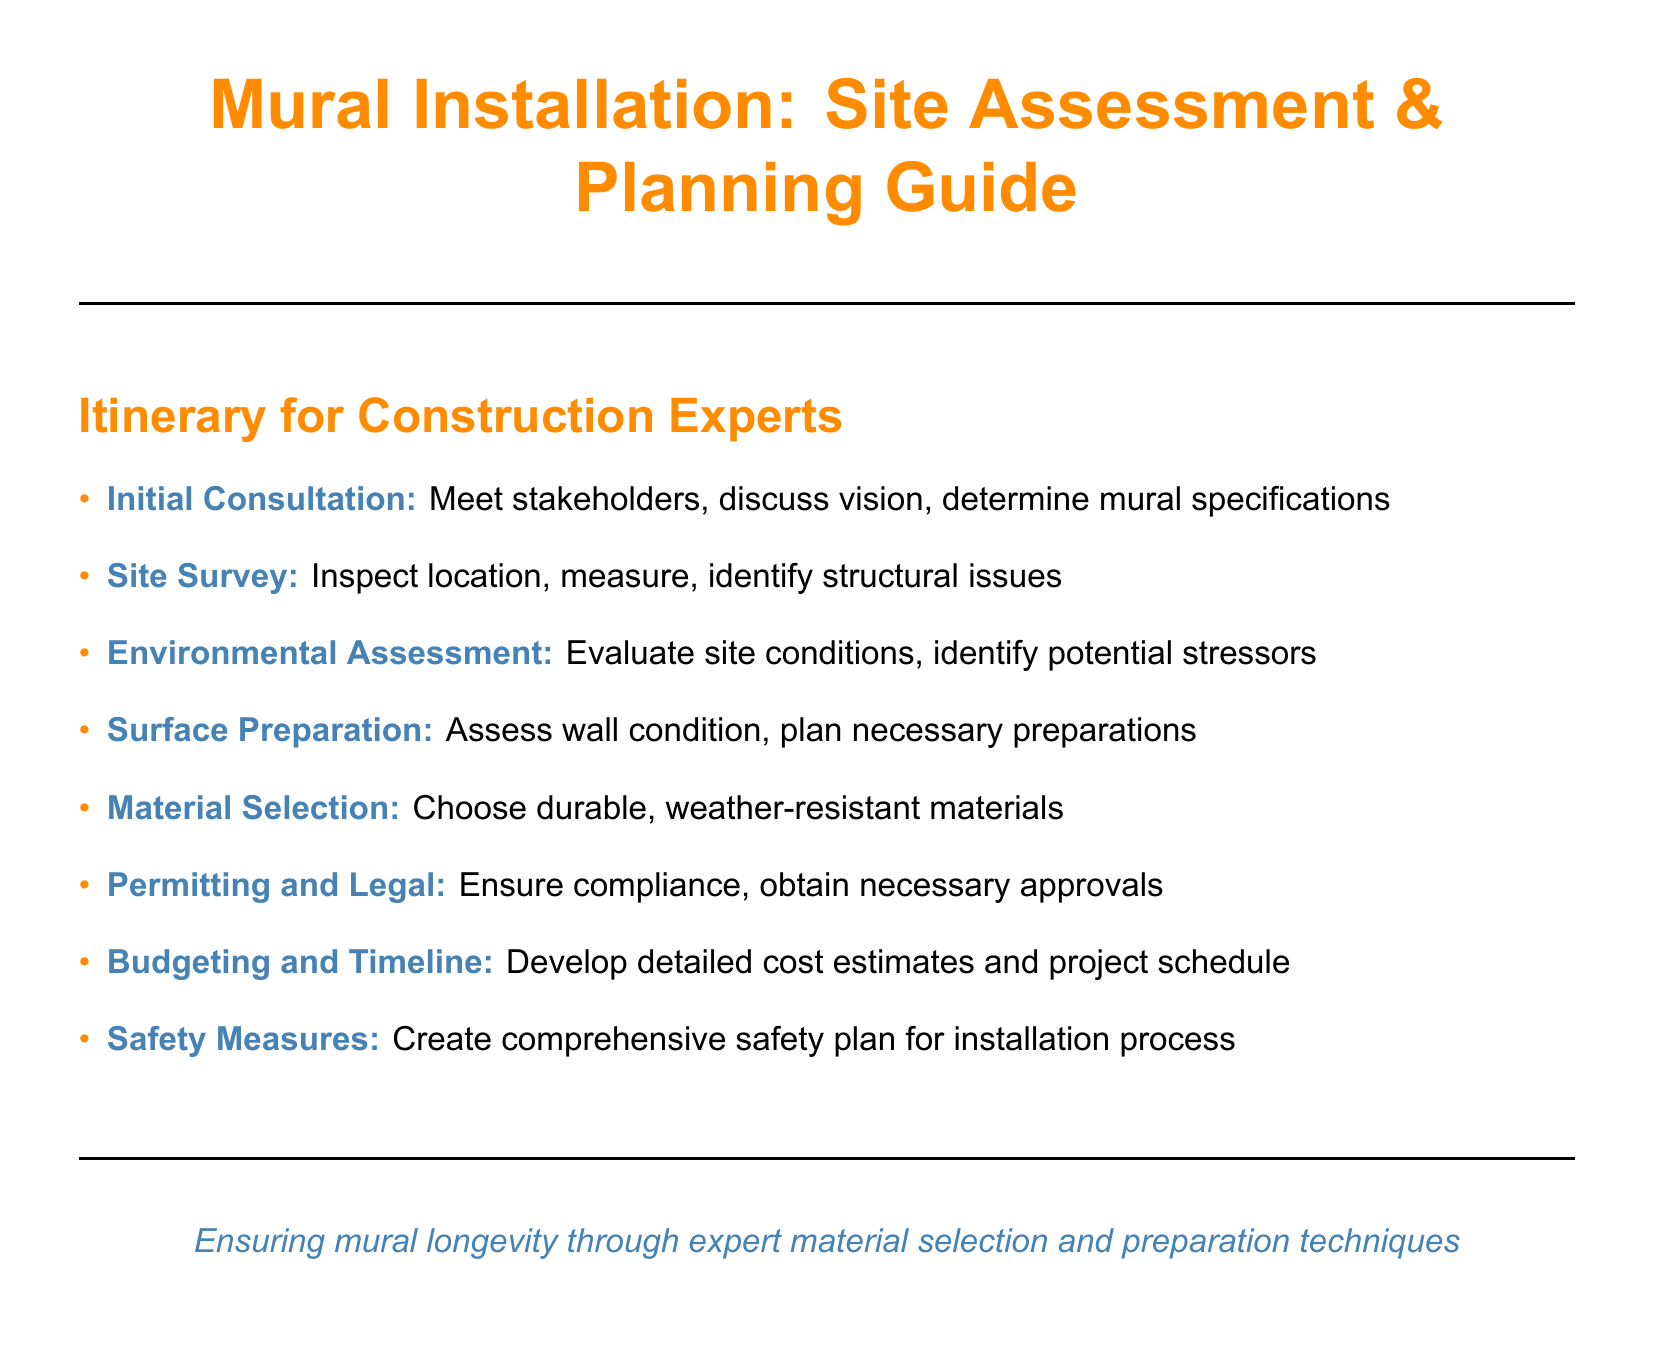What is the first step in the itinerary? The first step is the Initial Consultation, which involves meeting stakeholders and discussing the vision.
Answer: Initial Consultation What color is used for section titles? The section titles are formatted to use the color constructionOrange.
Answer: constructionOrange How many steps are listed in the itinerary? There are a total of eight steps mentioned in the itinerary for the mural installation process.
Answer: Eight What is the purpose of the Environmental Assessment step? The purpose is to evaluate site conditions and identify potential stressors.
Answer: Evaluate site conditions Which step involves material selection? The step that involves selecting durable, weather-resistant materials is titled Material Selection.
Answer: Material Selection What is emphasized at the end of the document? The ending emphasizes ensuring mural longevity through expert material selection and preparation techniques.
Answer: Mural longevity What document type does this itinerary represent? This itinerary is a step-by-step guide specifically for a mural installation process.
Answer: Step-by-step guide Which color is used to represent the main text? The main text is set to use the standard color, which is black.
Answer: Black 